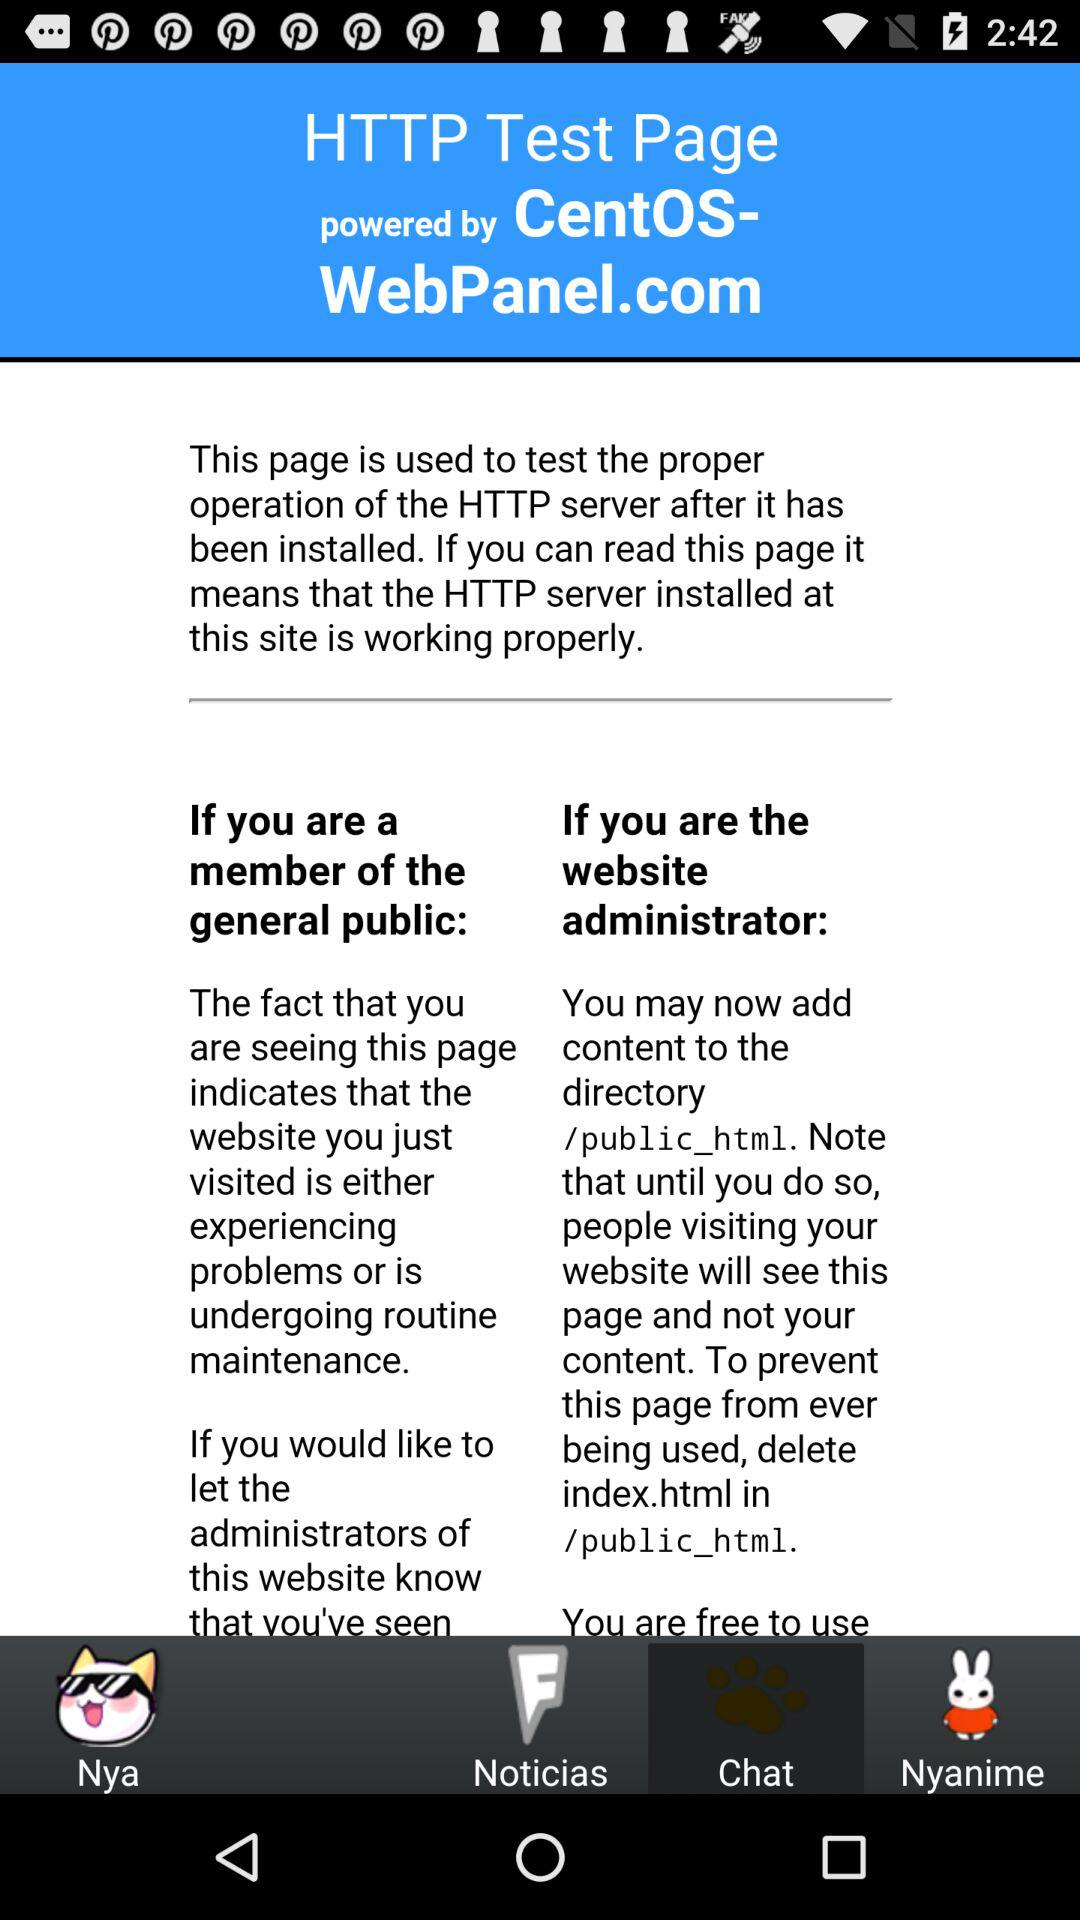By whom is the "HTTP Test Page" powered? The "HTTP Test Page" is powered by CentOS-WebPanel.com. 